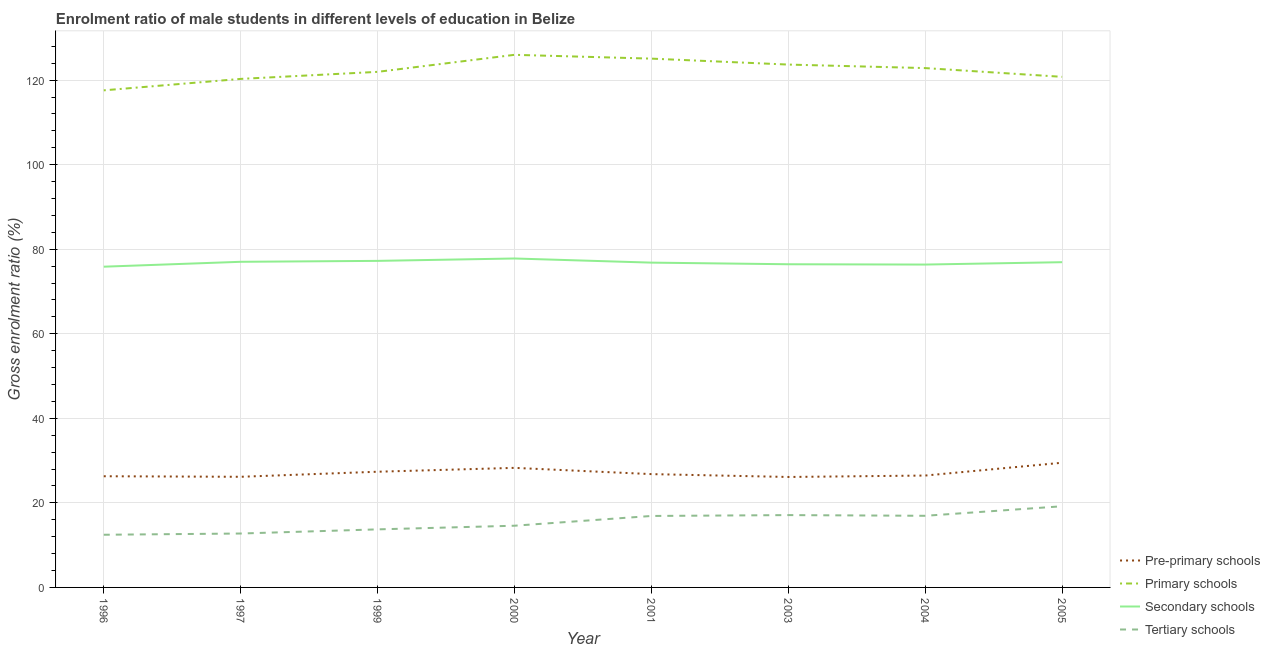Does the line corresponding to gross enrolment ratio(female) in tertiary schools intersect with the line corresponding to gross enrolment ratio(female) in pre-primary schools?
Give a very brief answer. No. What is the gross enrolment ratio(female) in pre-primary schools in 2005?
Your response must be concise. 29.49. Across all years, what is the maximum gross enrolment ratio(female) in primary schools?
Provide a succinct answer. 125.98. Across all years, what is the minimum gross enrolment ratio(female) in pre-primary schools?
Provide a succinct answer. 26.13. In which year was the gross enrolment ratio(female) in secondary schools maximum?
Offer a very short reply. 2000. In which year was the gross enrolment ratio(female) in tertiary schools minimum?
Offer a very short reply. 1996. What is the total gross enrolment ratio(female) in primary schools in the graph?
Offer a very short reply. 978.14. What is the difference between the gross enrolment ratio(female) in pre-primary schools in 1997 and that in 2005?
Your response must be concise. -3.32. What is the difference between the gross enrolment ratio(female) in primary schools in 2001 and the gross enrolment ratio(female) in pre-primary schools in 1999?
Your response must be concise. 97.71. What is the average gross enrolment ratio(female) in pre-primary schools per year?
Provide a succinct answer. 27.12. In the year 1997, what is the difference between the gross enrolment ratio(female) in pre-primary schools and gross enrolment ratio(female) in secondary schools?
Your response must be concise. -50.85. In how many years, is the gross enrolment ratio(female) in pre-primary schools greater than 44 %?
Your answer should be compact. 0. What is the ratio of the gross enrolment ratio(female) in pre-primary schools in 1996 to that in 2001?
Offer a terse response. 0.98. Is the difference between the gross enrolment ratio(female) in pre-primary schools in 1997 and 1999 greater than the difference between the gross enrolment ratio(female) in tertiary schools in 1997 and 1999?
Keep it short and to the point. No. What is the difference between the highest and the second highest gross enrolment ratio(female) in primary schools?
Your answer should be very brief. 0.9. What is the difference between the highest and the lowest gross enrolment ratio(female) in tertiary schools?
Provide a succinct answer. 6.74. Is the sum of the gross enrolment ratio(female) in tertiary schools in 1997 and 2000 greater than the maximum gross enrolment ratio(female) in primary schools across all years?
Provide a succinct answer. No. Is it the case that in every year, the sum of the gross enrolment ratio(female) in pre-primary schools and gross enrolment ratio(female) in primary schools is greater than the gross enrolment ratio(female) in secondary schools?
Give a very brief answer. Yes. Is the gross enrolment ratio(female) in primary schools strictly greater than the gross enrolment ratio(female) in tertiary schools over the years?
Your answer should be compact. Yes. How many years are there in the graph?
Make the answer very short. 8. Are the values on the major ticks of Y-axis written in scientific E-notation?
Your answer should be compact. No. Does the graph contain grids?
Your answer should be compact. Yes. How many legend labels are there?
Keep it short and to the point. 4. How are the legend labels stacked?
Keep it short and to the point. Vertical. What is the title of the graph?
Ensure brevity in your answer.  Enrolment ratio of male students in different levels of education in Belize. What is the Gross enrolment ratio (%) of Pre-primary schools in 1996?
Your answer should be compact. 26.3. What is the Gross enrolment ratio (%) of Primary schools in 1996?
Give a very brief answer. 117.58. What is the Gross enrolment ratio (%) in Secondary schools in 1996?
Offer a very short reply. 75.86. What is the Gross enrolment ratio (%) in Tertiary schools in 1996?
Keep it short and to the point. 12.46. What is the Gross enrolment ratio (%) of Pre-primary schools in 1997?
Keep it short and to the point. 26.17. What is the Gross enrolment ratio (%) of Primary schools in 1997?
Give a very brief answer. 120.28. What is the Gross enrolment ratio (%) of Secondary schools in 1997?
Ensure brevity in your answer.  77.02. What is the Gross enrolment ratio (%) in Tertiary schools in 1997?
Your response must be concise. 12.75. What is the Gross enrolment ratio (%) of Pre-primary schools in 1999?
Ensure brevity in your answer.  27.37. What is the Gross enrolment ratio (%) of Primary schools in 1999?
Your answer should be very brief. 121.95. What is the Gross enrolment ratio (%) in Secondary schools in 1999?
Provide a short and direct response. 77.24. What is the Gross enrolment ratio (%) of Tertiary schools in 1999?
Give a very brief answer. 13.73. What is the Gross enrolment ratio (%) in Pre-primary schools in 2000?
Provide a succinct answer. 28.28. What is the Gross enrolment ratio (%) of Primary schools in 2000?
Your response must be concise. 125.98. What is the Gross enrolment ratio (%) of Secondary schools in 2000?
Your answer should be very brief. 77.8. What is the Gross enrolment ratio (%) in Tertiary schools in 2000?
Offer a terse response. 14.6. What is the Gross enrolment ratio (%) of Pre-primary schools in 2001?
Ensure brevity in your answer.  26.8. What is the Gross enrolment ratio (%) of Primary schools in 2001?
Give a very brief answer. 125.08. What is the Gross enrolment ratio (%) of Secondary schools in 2001?
Offer a very short reply. 76.82. What is the Gross enrolment ratio (%) of Tertiary schools in 2001?
Provide a short and direct response. 16.9. What is the Gross enrolment ratio (%) of Pre-primary schools in 2003?
Your answer should be very brief. 26.13. What is the Gross enrolment ratio (%) of Primary schools in 2003?
Ensure brevity in your answer.  123.67. What is the Gross enrolment ratio (%) of Secondary schools in 2003?
Keep it short and to the point. 76.44. What is the Gross enrolment ratio (%) in Tertiary schools in 2003?
Make the answer very short. 17.11. What is the Gross enrolment ratio (%) of Pre-primary schools in 2004?
Your answer should be compact. 26.46. What is the Gross enrolment ratio (%) of Primary schools in 2004?
Provide a succinct answer. 122.84. What is the Gross enrolment ratio (%) of Secondary schools in 2004?
Offer a terse response. 76.37. What is the Gross enrolment ratio (%) in Tertiary schools in 2004?
Provide a succinct answer. 16.94. What is the Gross enrolment ratio (%) in Pre-primary schools in 2005?
Provide a succinct answer. 29.49. What is the Gross enrolment ratio (%) of Primary schools in 2005?
Offer a terse response. 120.77. What is the Gross enrolment ratio (%) of Secondary schools in 2005?
Keep it short and to the point. 76.93. What is the Gross enrolment ratio (%) in Tertiary schools in 2005?
Give a very brief answer. 19.2. Across all years, what is the maximum Gross enrolment ratio (%) in Pre-primary schools?
Keep it short and to the point. 29.49. Across all years, what is the maximum Gross enrolment ratio (%) in Primary schools?
Ensure brevity in your answer.  125.98. Across all years, what is the maximum Gross enrolment ratio (%) in Secondary schools?
Your response must be concise. 77.8. Across all years, what is the maximum Gross enrolment ratio (%) in Tertiary schools?
Your answer should be compact. 19.2. Across all years, what is the minimum Gross enrolment ratio (%) of Pre-primary schools?
Your response must be concise. 26.13. Across all years, what is the minimum Gross enrolment ratio (%) in Primary schools?
Provide a succinct answer. 117.58. Across all years, what is the minimum Gross enrolment ratio (%) of Secondary schools?
Keep it short and to the point. 75.86. Across all years, what is the minimum Gross enrolment ratio (%) in Tertiary schools?
Ensure brevity in your answer.  12.46. What is the total Gross enrolment ratio (%) of Pre-primary schools in the graph?
Your answer should be very brief. 217. What is the total Gross enrolment ratio (%) of Primary schools in the graph?
Provide a short and direct response. 978.14. What is the total Gross enrolment ratio (%) in Secondary schools in the graph?
Give a very brief answer. 614.49. What is the total Gross enrolment ratio (%) in Tertiary schools in the graph?
Make the answer very short. 123.69. What is the difference between the Gross enrolment ratio (%) in Pre-primary schools in 1996 and that in 1997?
Your answer should be very brief. 0.13. What is the difference between the Gross enrolment ratio (%) of Primary schools in 1996 and that in 1997?
Offer a very short reply. -2.71. What is the difference between the Gross enrolment ratio (%) of Secondary schools in 1996 and that in 1997?
Keep it short and to the point. -1.16. What is the difference between the Gross enrolment ratio (%) of Tertiary schools in 1996 and that in 1997?
Provide a succinct answer. -0.29. What is the difference between the Gross enrolment ratio (%) of Pre-primary schools in 1996 and that in 1999?
Keep it short and to the point. -1.07. What is the difference between the Gross enrolment ratio (%) in Primary schools in 1996 and that in 1999?
Give a very brief answer. -4.37. What is the difference between the Gross enrolment ratio (%) in Secondary schools in 1996 and that in 1999?
Keep it short and to the point. -1.38. What is the difference between the Gross enrolment ratio (%) of Tertiary schools in 1996 and that in 1999?
Your response must be concise. -1.27. What is the difference between the Gross enrolment ratio (%) in Pre-primary schools in 1996 and that in 2000?
Provide a succinct answer. -1.98. What is the difference between the Gross enrolment ratio (%) of Primary schools in 1996 and that in 2000?
Keep it short and to the point. -8.4. What is the difference between the Gross enrolment ratio (%) in Secondary schools in 1996 and that in 2000?
Make the answer very short. -1.94. What is the difference between the Gross enrolment ratio (%) of Tertiary schools in 1996 and that in 2000?
Offer a very short reply. -2.14. What is the difference between the Gross enrolment ratio (%) of Pre-primary schools in 1996 and that in 2001?
Ensure brevity in your answer.  -0.5. What is the difference between the Gross enrolment ratio (%) of Primary schools in 1996 and that in 2001?
Provide a short and direct response. -7.5. What is the difference between the Gross enrolment ratio (%) of Secondary schools in 1996 and that in 2001?
Give a very brief answer. -0.96. What is the difference between the Gross enrolment ratio (%) in Tertiary schools in 1996 and that in 2001?
Ensure brevity in your answer.  -4.44. What is the difference between the Gross enrolment ratio (%) in Pre-primary schools in 1996 and that in 2003?
Give a very brief answer. 0.17. What is the difference between the Gross enrolment ratio (%) in Primary schools in 1996 and that in 2003?
Offer a very short reply. -6.1. What is the difference between the Gross enrolment ratio (%) of Secondary schools in 1996 and that in 2003?
Offer a terse response. -0.58. What is the difference between the Gross enrolment ratio (%) in Tertiary schools in 1996 and that in 2003?
Make the answer very short. -4.65. What is the difference between the Gross enrolment ratio (%) of Pre-primary schools in 1996 and that in 2004?
Keep it short and to the point. -0.17. What is the difference between the Gross enrolment ratio (%) in Primary schools in 1996 and that in 2004?
Ensure brevity in your answer.  -5.26. What is the difference between the Gross enrolment ratio (%) of Secondary schools in 1996 and that in 2004?
Give a very brief answer. -0.5. What is the difference between the Gross enrolment ratio (%) of Tertiary schools in 1996 and that in 2004?
Provide a short and direct response. -4.48. What is the difference between the Gross enrolment ratio (%) in Pre-primary schools in 1996 and that in 2005?
Offer a terse response. -3.2. What is the difference between the Gross enrolment ratio (%) in Primary schools in 1996 and that in 2005?
Ensure brevity in your answer.  -3.2. What is the difference between the Gross enrolment ratio (%) in Secondary schools in 1996 and that in 2005?
Your answer should be compact. -1.06. What is the difference between the Gross enrolment ratio (%) in Tertiary schools in 1996 and that in 2005?
Give a very brief answer. -6.74. What is the difference between the Gross enrolment ratio (%) of Pre-primary schools in 1997 and that in 1999?
Give a very brief answer. -1.2. What is the difference between the Gross enrolment ratio (%) of Primary schools in 1997 and that in 1999?
Your response must be concise. -1.67. What is the difference between the Gross enrolment ratio (%) of Secondary schools in 1997 and that in 1999?
Your answer should be very brief. -0.22. What is the difference between the Gross enrolment ratio (%) of Tertiary schools in 1997 and that in 1999?
Make the answer very short. -0.98. What is the difference between the Gross enrolment ratio (%) in Pre-primary schools in 1997 and that in 2000?
Provide a succinct answer. -2.11. What is the difference between the Gross enrolment ratio (%) in Primary schools in 1997 and that in 2000?
Make the answer very short. -5.7. What is the difference between the Gross enrolment ratio (%) of Secondary schools in 1997 and that in 2000?
Your answer should be compact. -0.78. What is the difference between the Gross enrolment ratio (%) in Tertiary schools in 1997 and that in 2000?
Provide a short and direct response. -1.84. What is the difference between the Gross enrolment ratio (%) in Pre-primary schools in 1997 and that in 2001?
Give a very brief answer. -0.63. What is the difference between the Gross enrolment ratio (%) in Primary schools in 1997 and that in 2001?
Ensure brevity in your answer.  -4.8. What is the difference between the Gross enrolment ratio (%) in Secondary schools in 1997 and that in 2001?
Provide a succinct answer. 0.2. What is the difference between the Gross enrolment ratio (%) in Tertiary schools in 1997 and that in 2001?
Your response must be concise. -4.15. What is the difference between the Gross enrolment ratio (%) in Pre-primary schools in 1997 and that in 2003?
Keep it short and to the point. 0.04. What is the difference between the Gross enrolment ratio (%) of Primary schools in 1997 and that in 2003?
Offer a very short reply. -3.39. What is the difference between the Gross enrolment ratio (%) of Secondary schools in 1997 and that in 2003?
Offer a terse response. 0.58. What is the difference between the Gross enrolment ratio (%) in Tertiary schools in 1997 and that in 2003?
Give a very brief answer. -4.36. What is the difference between the Gross enrolment ratio (%) in Pre-primary schools in 1997 and that in 2004?
Your response must be concise. -0.29. What is the difference between the Gross enrolment ratio (%) of Primary schools in 1997 and that in 2004?
Ensure brevity in your answer.  -2.56. What is the difference between the Gross enrolment ratio (%) in Secondary schools in 1997 and that in 2004?
Make the answer very short. 0.65. What is the difference between the Gross enrolment ratio (%) of Tertiary schools in 1997 and that in 2004?
Your response must be concise. -4.19. What is the difference between the Gross enrolment ratio (%) in Pre-primary schools in 1997 and that in 2005?
Your answer should be very brief. -3.32. What is the difference between the Gross enrolment ratio (%) of Primary schools in 1997 and that in 2005?
Keep it short and to the point. -0.49. What is the difference between the Gross enrolment ratio (%) of Secondary schools in 1997 and that in 2005?
Offer a terse response. 0.09. What is the difference between the Gross enrolment ratio (%) of Tertiary schools in 1997 and that in 2005?
Keep it short and to the point. -6.45. What is the difference between the Gross enrolment ratio (%) in Pre-primary schools in 1999 and that in 2000?
Give a very brief answer. -0.91. What is the difference between the Gross enrolment ratio (%) of Primary schools in 1999 and that in 2000?
Offer a terse response. -4.03. What is the difference between the Gross enrolment ratio (%) in Secondary schools in 1999 and that in 2000?
Provide a succinct answer. -0.56. What is the difference between the Gross enrolment ratio (%) in Tertiary schools in 1999 and that in 2000?
Your answer should be very brief. -0.86. What is the difference between the Gross enrolment ratio (%) in Pre-primary schools in 1999 and that in 2001?
Keep it short and to the point. 0.56. What is the difference between the Gross enrolment ratio (%) of Primary schools in 1999 and that in 2001?
Keep it short and to the point. -3.13. What is the difference between the Gross enrolment ratio (%) of Secondary schools in 1999 and that in 2001?
Offer a terse response. 0.42. What is the difference between the Gross enrolment ratio (%) of Tertiary schools in 1999 and that in 2001?
Your answer should be compact. -3.17. What is the difference between the Gross enrolment ratio (%) of Pre-primary schools in 1999 and that in 2003?
Offer a very short reply. 1.24. What is the difference between the Gross enrolment ratio (%) in Primary schools in 1999 and that in 2003?
Your answer should be very brief. -1.72. What is the difference between the Gross enrolment ratio (%) in Secondary schools in 1999 and that in 2003?
Provide a short and direct response. 0.8. What is the difference between the Gross enrolment ratio (%) in Tertiary schools in 1999 and that in 2003?
Make the answer very short. -3.38. What is the difference between the Gross enrolment ratio (%) in Pre-primary schools in 1999 and that in 2004?
Your answer should be very brief. 0.9. What is the difference between the Gross enrolment ratio (%) of Primary schools in 1999 and that in 2004?
Your answer should be very brief. -0.89. What is the difference between the Gross enrolment ratio (%) in Secondary schools in 1999 and that in 2004?
Your response must be concise. 0.87. What is the difference between the Gross enrolment ratio (%) in Tertiary schools in 1999 and that in 2004?
Your answer should be compact. -3.21. What is the difference between the Gross enrolment ratio (%) of Pre-primary schools in 1999 and that in 2005?
Provide a succinct answer. -2.13. What is the difference between the Gross enrolment ratio (%) of Primary schools in 1999 and that in 2005?
Ensure brevity in your answer.  1.18. What is the difference between the Gross enrolment ratio (%) in Secondary schools in 1999 and that in 2005?
Provide a short and direct response. 0.31. What is the difference between the Gross enrolment ratio (%) in Tertiary schools in 1999 and that in 2005?
Your answer should be very brief. -5.47. What is the difference between the Gross enrolment ratio (%) of Pre-primary schools in 2000 and that in 2001?
Your answer should be compact. 1.48. What is the difference between the Gross enrolment ratio (%) in Primary schools in 2000 and that in 2001?
Your response must be concise. 0.9. What is the difference between the Gross enrolment ratio (%) in Secondary schools in 2000 and that in 2001?
Keep it short and to the point. 0.98. What is the difference between the Gross enrolment ratio (%) in Tertiary schools in 2000 and that in 2001?
Provide a short and direct response. -2.31. What is the difference between the Gross enrolment ratio (%) in Pre-primary schools in 2000 and that in 2003?
Your answer should be very brief. 2.15. What is the difference between the Gross enrolment ratio (%) in Primary schools in 2000 and that in 2003?
Provide a succinct answer. 2.31. What is the difference between the Gross enrolment ratio (%) in Secondary schools in 2000 and that in 2003?
Offer a very short reply. 1.36. What is the difference between the Gross enrolment ratio (%) in Tertiary schools in 2000 and that in 2003?
Give a very brief answer. -2.51. What is the difference between the Gross enrolment ratio (%) in Pre-primary schools in 2000 and that in 2004?
Offer a terse response. 1.82. What is the difference between the Gross enrolment ratio (%) of Primary schools in 2000 and that in 2004?
Ensure brevity in your answer.  3.14. What is the difference between the Gross enrolment ratio (%) of Secondary schools in 2000 and that in 2004?
Offer a very short reply. 1.44. What is the difference between the Gross enrolment ratio (%) of Tertiary schools in 2000 and that in 2004?
Your response must be concise. -2.35. What is the difference between the Gross enrolment ratio (%) of Pre-primary schools in 2000 and that in 2005?
Make the answer very short. -1.21. What is the difference between the Gross enrolment ratio (%) in Primary schools in 2000 and that in 2005?
Give a very brief answer. 5.21. What is the difference between the Gross enrolment ratio (%) in Secondary schools in 2000 and that in 2005?
Offer a very short reply. 0.88. What is the difference between the Gross enrolment ratio (%) in Tertiary schools in 2000 and that in 2005?
Your answer should be compact. -4.6. What is the difference between the Gross enrolment ratio (%) in Pre-primary schools in 2001 and that in 2003?
Ensure brevity in your answer.  0.68. What is the difference between the Gross enrolment ratio (%) in Primary schools in 2001 and that in 2003?
Your answer should be very brief. 1.41. What is the difference between the Gross enrolment ratio (%) in Secondary schools in 2001 and that in 2003?
Your answer should be compact. 0.38. What is the difference between the Gross enrolment ratio (%) of Tertiary schools in 2001 and that in 2003?
Make the answer very short. -0.2. What is the difference between the Gross enrolment ratio (%) of Pre-primary schools in 2001 and that in 2004?
Provide a short and direct response. 0.34. What is the difference between the Gross enrolment ratio (%) of Primary schools in 2001 and that in 2004?
Offer a very short reply. 2.24. What is the difference between the Gross enrolment ratio (%) of Secondary schools in 2001 and that in 2004?
Your answer should be very brief. 0.46. What is the difference between the Gross enrolment ratio (%) of Tertiary schools in 2001 and that in 2004?
Offer a terse response. -0.04. What is the difference between the Gross enrolment ratio (%) of Pre-primary schools in 2001 and that in 2005?
Make the answer very short. -2.69. What is the difference between the Gross enrolment ratio (%) in Primary schools in 2001 and that in 2005?
Your response must be concise. 4.31. What is the difference between the Gross enrolment ratio (%) of Secondary schools in 2001 and that in 2005?
Provide a short and direct response. -0.11. What is the difference between the Gross enrolment ratio (%) in Tertiary schools in 2001 and that in 2005?
Offer a terse response. -2.3. What is the difference between the Gross enrolment ratio (%) in Pre-primary schools in 2003 and that in 2004?
Make the answer very short. -0.34. What is the difference between the Gross enrolment ratio (%) of Primary schools in 2003 and that in 2004?
Give a very brief answer. 0.83. What is the difference between the Gross enrolment ratio (%) of Secondary schools in 2003 and that in 2004?
Give a very brief answer. 0.07. What is the difference between the Gross enrolment ratio (%) in Tertiary schools in 2003 and that in 2004?
Keep it short and to the point. 0.17. What is the difference between the Gross enrolment ratio (%) in Pre-primary schools in 2003 and that in 2005?
Your answer should be very brief. -3.37. What is the difference between the Gross enrolment ratio (%) of Primary schools in 2003 and that in 2005?
Offer a terse response. 2.9. What is the difference between the Gross enrolment ratio (%) in Secondary schools in 2003 and that in 2005?
Your answer should be very brief. -0.49. What is the difference between the Gross enrolment ratio (%) in Tertiary schools in 2003 and that in 2005?
Provide a short and direct response. -2.09. What is the difference between the Gross enrolment ratio (%) in Pre-primary schools in 2004 and that in 2005?
Your response must be concise. -3.03. What is the difference between the Gross enrolment ratio (%) of Primary schools in 2004 and that in 2005?
Offer a very short reply. 2.07. What is the difference between the Gross enrolment ratio (%) of Secondary schools in 2004 and that in 2005?
Provide a succinct answer. -0.56. What is the difference between the Gross enrolment ratio (%) in Tertiary schools in 2004 and that in 2005?
Provide a short and direct response. -2.26. What is the difference between the Gross enrolment ratio (%) of Pre-primary schools in 1996 and the Gross enrolment ratio (%) of Primary schools in 1997?
Keep it short and to the point. -93.98. What is the difference between the Gross enrolment ratio (%) of Pre-primary schools in 1996 and the Gross enrolment ratio (%) of Secondary schools in 1997?
Offer a terse response. -50.72. What is the difference between the Gross enrolment ratio (%) in Pre-primary schools in 1996 and the Gross enrolment ratio (%) in Tertiary schools in 1997?
Keep it short and to the point. 13.55. What is the difference between the Gross enrolment ratio (%) of Primary schools in 1996 and the Gross enrolment ratio (%) of Secondary schools in 1997?
Your answer should be very brief. 40.55. What is the difference between the Gross enrolment ratio (%) in Primary schools in 1996 and the Gross enrolment ratio (%) in Tertiary schools in 1997?
Your answer should be compact. 104.82. What is the difference between the Gross enrolment ratio (%) of Secondary schools in 1996 and the Gross enrolment ratio (%) of Tertiary schools in 1997?
Your answer should be very brief. 63.11. What is the difference between the Gross enrolment ratio (%) in Pre-primary schools in 1996 and the Gross enrolment ratio (%) in Primary schools in 1999?
Make the answer very short. -95.65. What is the difference between the Gross enrolment ratio (%) in Pre-primary schools in 1996 and the Gross enrolment ratio (%) in Secondary schools in 1999?
Give a very brief answer. -50.94. What is the difference between the Gross enrolment ratio (%) in Pre-primary schools in 1996 and the Gross enrolment ratio (%) in Tertiary schools in 1999?
Your answer should be compact. 12.57. What is the difference between the Gross enrolment ratio (%) of Primary schools in 1996 and the Gross enrolment ratio (%) of Secondary schools in 1999?
Provide a succinct answer. 40.33. What is the difference between the Gross enrolment ratio (%) in Primary schools in 1996 and the Gross enrolment ratio (%) in Tertiary schools in 1999?
Your response must be concise. 103.84. What is the difference between the Gross enrolment ratio (%) in Secondary schools in 1996 and the Gross enrolment ratio (%) in Tertiary schools in 1999?
Your answer should be compact. 62.13. What is the difference between the Gross enrolment ratio (%) of Pre-primary schools in 1996 and the Gross enrolment ratio (%) of Primary schools in 2000?
Ensure brevity in your answer.  -99.68. What is the difference between the Gross enrolment ratio (%) in Pre-primary schools in 1996 and the Gross enrolment ratio (%) in Secondary schools in 2000?
Your response must be concise. -51.51. What is the difference between the Gross enrolment ratio (%) of Pre-primary schools in 1996 and the Gross enrolment ratio (%) of Tertiary schools in 2000?
Give a very brief answer. 11.7. What is the difference between the Gross enrolment ratio (%) in Primary schools in 1996 and the Gross enrolment ratio (%) in Secondary schools in 2000?
Provide a short and direct response. 39.77. What is the difference between the Gross enrolment ratio (%) of Primary schools in 1996 and the Gross enrolment ratio (%) of Tertiary schools in 2000?
Make the answer very short. 102.98. What is the difference between the Gross enrolment ratio (%) of Secondary schools in 1996 and the Gross enrolment ratio (%) of Tertiary schools in 2000?
Provide a short and direct response. 61.27. What is the difference between the Gross enrolment ratio (%) in Pre-primary schools in 1996 and the Gross enrolment ratio (%) in Primary schools in 2001?
Your answer should be very brief. -98.78. What is the difference between the Gross enrolment ratio (%) of Pre-primary schools in 1996 and the Gross enrolment ratio (%) of Secondary schools in 2001?
Ensure brevity in your answer.  -50.53. What is the difference between the Gross enrolment ratio (%) of Pre-primary schools in 1996 and the Gross enrolment ratio (%) of Tertiary schools in 2001?
Your answer should be very brief. 9.39. What is the difference between the Gross enrolment ratio (%) of Primary schools in 1996 and the Gross enrolment ratio (%) of Secondary schools in 2001?
Provide a short and direct response. 40.75. What is the difference between the Gross enrolment ratio (%) in Primary schools in 1996 and the Gross enrolment ratio (%) in Tertiary schools in 2001?
Your response must be concise. 100.67. What is the difference between the Gross enrolment ratio (%) in Secondary schools in 1996 and the Gross enrolment ratio (%) in Tertiary schools in 2001?
Give a very brief answer. 58.96. What is the difference between the Gross enrolment ratio (%) in Pre-primary schools in 1996 and the Gross enrolment ratio (%) in Primary schools in 2003?
Your answer should be compact. -97.37. What is the difference between the Gross enrolment ratio (%) in Pre-primary schools in 1996 and the Gross enrolment ratio (%) in Secondary schools in 2003?
Make the answer very short. -50.14. What is the difference between the Gross enrolment ratio (%) in Pre-primary schools in 1996 and the Gross enrolment ratio (%) in Tertiary schools in 2003?
Your answer should be compact. 9.19. What is the difference between the Gross enrolment ratio (%) of Primary schools in 1996 and the Gross enrolment ratio (%) of Secondary schools in 2003?
Your answer should be very brief. 41.13. What is the difference between the Gross enrolment ratio (%) of Primary schools in 1996 and the Gross enrolment ratio (%) of Tertiary schools in 2003?
Keep it short and to the point. 100.47. What is the difference between the Gross enrolment ratio (%) in Secondary schools in 1996 and the Gross enrolment ratio (%) in Tertiary schools in 2003?
Offer a very short reply. 58.76. What is the difference between the Gross enrolment ratio (%) in Pre-primary schools in 1996 and the Gross enrolment ratio (%) in Primary schools in 2004?
Make the answer very short. -96.54. What is the difference between the Gross enrolment ratio (%) in Pre-primary schools in 1996 and the Gross enrolment ratio (%) in Secondary schools in 2004?
Provide a short and direct response. -50.07. What is the difference between the Gross enrolment ratio (%) in Pre-primary schools in 1996 and the Gross enrolment ratio (%) in Tertiary schools in 2004?
Your response must be concise. 9.35. What is the difference between the Gross enrolment ratio (%) in Primary schools in 1996 and the Gross enrolment ratio (%) in Secondary schools in 2004?
Provide a short and direct response. 41.21. What is the difference between the Gross enrolment ratio (%) in Primary schools in 1996 and the Gross enrolment ratio (%) in Tertiary schools in 2004?
Ensure brevity in your answer.  100.63. What is the difference between the Gross enrolment ratio (%) of Secondary schools in 1996 and the Gross enrolment ratio (%) of Tertiary schools in 2004?
Offer a terse response. 58.92. What is the difference between the Gross enrolment ratio (%) of Pre-primary schools in 1996 and the Gross enrolment ratio (%) of Primary schools in 2005?
Your answer should be very brief. -94.47. What is the difference between the Gross enrolment ratio (%) in Pre-primary schools in 1996 and the Gross enrolment ratio (%) in Secondary schools in 2005?
Your answer should be very brief. -50.63. What is the difference between the Gross enrolment ratio (%) in Pre-primary schools in 1996 and the Gross enrolment ratio (%) in Tertiary schools in 2005?
Give a very brief answer. 7.1. What is the difference between the Gross enrolment ratio (%) in Primary schools in 1996 and the Gross enrolment ratio (%) in Secondary schools in 2005?
Ensure brevity in your answer.  40.65. What is the difference between the Gross enrolment ratio (%) in Primary schools in 1996 and the Gross enrolment ratio (%) in Tertiary schools in 2005?
Your answer should be compact. 98.38. What is the difference between the Gross enrolment ratio (%) in Secondary schools in 1996 and the Gross enrolment ratio (%) in Tertiary schools in 2005?
Your response must be concise. 56.67. What is the difference between the Gross enrolment ratio (%) in Pre-primary schools in 1997 and the Gross enrolment ratio (%) in Primary schools in 1999?
Give a very brief answer. -95.78. What is the difference between the Gross enrolment ratio (%) of Pre-primary schools in 1997 and the Gross enrolment ratio (%) of Secondary schools in 1999?
Offer a terse response. -51.07. What is the difference between the Gross enrolment ratio (%) in Pre-primary schools in 1997 and the Gross enrolment ratio (%) in Tertiary schools in 1999?
Your answer should be compact. 12.44. What is the difference between the Gross enrolment ratio (%) in Primary schools in 1997 and the Gross enrolment ratio (%) in Secondary schools in 1999?
Ensure brevity in your answer.  43.04. What is the difference between the Gross enrolment ratio (%) in Primary schools in 1997 and the Gross enrolment ratio (%) in Tertiary schools in 1999?
Your answer should be compact. 106.55. What is the difference between the Gross enrolment ratio (%) of Secondary schools in 1997 and the Gross enrolment ratio (%) of Tertiary schools in 1999?
Your answer should be compact. 63.29. What is the difference between the Gross enrolment ratio (%) in Pre-primary schools in 1997 and the Gross enrolment ratio (%) in Primary schools in 2000?
Your answer should be very brief. -99.81. What is the difference between the Gross enrolment ratio (%) of Pre-primary schools in 1997 and the Gross enrolment ratio (%) of Secondary schools in 2000?
Provide a short and direct response. -51.63. What is the difference between the Gross enrolment ratio (%) in Pre-primary schools in 1997 and the Gross enrolment ratio (%) in Tertiary schools in 2000?
Give a very brief answer. 11.57. What is the difference between the Gross enrolment ratio (%) of Primary schools in 1997 and the Gross enrolment ratio (%) of Secondary schools in 2000?
Give a very brief answer. 42.48. What is the difference between the Gross enrolment ratio (%) in Primary schools in 1997 and the Gross enrolment ratio (%) in Tertiary schools in 2000?
Your answer should be compact. 105.68. What is the difference between the Gross enrolment ratio (%) of Secondary schools in 1997 and the Gross enrolment ratio (%) of Tertiary schools in 2000?
Make the answer very short. 62.42. What is the difference between the Gross enrolment ratio (%) in Pre-primary schools in 1997 and the Gross enrolment ratio (%) in Primary schools in 2001?
Give a very brief answer. -98.91. What is the difference between the Gross enrolment ratio (%) in Pre-primary schools in 1997 and the Gross enrolment ratio (%) in Secondary schools in 2001?
Keep it short and to the point. -50.65. What is the difference between the Gross enrolment ratio (%) in Pre-primary schools in 1997 and the Gross enrolment ratio (%) in Tertiary schools in 2001?
Offer a terse response. 9.27. What is the difference between the Gross enrolment ratio (%) in Primary schools in 1997 and the Gross enrolment ratio (%) in Secondary schools in 2001?
Ensure brevity in your answer.  43.46. What is the difference between the Gross enrolment ratio (%) of Primary schools in 1997 and the Gross enrolment ratio (%) of Tertiary schools in 2001?
Offer a terse response. 103.38. What is the difference between the Gross enrolment ratio (%) in Secondary schools in 1997 and the Gross enrolment ratio (%) in Tertiary schools in 2001?
Offer a very short reply. 60.12. What is the difference between the Gross enrolment ratio (%) in Pre-primary schools in 1997 and the Gross enrolment ratio (%) in Primary schools in 2003?
Give a very brief answer. -97.5. What is the difference between the Gross enrolment ratio (%) in Pre-primary schools in 1997 and the Gross enrolment ratio (%) in Secondary schools in 2003?
Provide a short and direct response. -50.27. What is the difference between the Gross enrolment ratio (%) of Pre-primary schools in 1997 and the Gross enrolment ratio (%) of Tertiary schools in 2003?
Keep it short and to the point. 9.06. What is the difference between the Gross enrolment ratio (%) in Primary schools in 1997 and the Gross enrolment ratio (%) in Secondary schools in 2003?
Provide a short and direct response. 43.84. What is the difference between the Gross enrolment ratio (%) in Primary schools in 1997 and the Gross enrolment ratio (%) in Tertiary schools in 2003?
Your response must be concise. 103.17. What is the difference between the Gross enrolment ratio (%) in Secondary schools in 1997 and the Gross enrolment ratio (%) in Tertiary schools in 2003?
Provide a short and direct response. 59.91. What is the difference between the Gross enrolment ratio (%) of Pre-primary schools in 1997 and the Gross enrolment ratio (%) of Primary schools in 2004?
Keep it short and to the point. -96.67. What is the difference between the Gross enrolment ratio (%) of Pre-primary schools in 1997 and the Gross enrolment ratio (%) of Secondary schools in 2004?
Make the answer very short. -50.2. What is the difference between the Gross enrolment ratio (%) of Pre-primary schools in 1997 and the Gross enrolment ratio (%) of Tertiary schools in 2004?
Your answer should be compact. 9.23. What is the difference between the Gross enrolment ratio (%) of Primary schools in 1997 and the Gross enrolment ratio (%) of Secondary schools in 2004?
Your answer should be compact. 43.91. What is the difference between the Gross enrolment ratio (%) of Primary schools in 1997 and the Gross enrolment ratio (%) of Tertiary schools in 2004?
Your answer should be compact. 103.34. What is the difference between the Gross enrolment ratio (%) in Secondary schools in 1997 and the Gross enrolment ratio (%) in Tertiary schools in 2004?
Your response must be concise. 60.08. What is the difference between the Gross enrolment ratio (%) of Pre-primary schools in 1997 and the Gross enrolment ratio (%) of Primary schools in 2005?
Make the answer very short. -94.6. What is the difference between the Gross enrolment ratio (%) in Pre-primary schools in 1997 and the Gross enrolment ratio (%) in Secondary schools in 2005?
Provide a succinct answer. -50.76. What is the difference between the Gross enrolment ratio (%) in Pre-primary schools in 1997 and the Gross enrolment ratio (%) in Tertiary schools in 2005?
Offer a very short reply. 6.97. What is the difference between the Gross enrolment ratio (%) in Primary schools in 1997 and the Gross enrolment ratio (%) in Secondary schools in 2005?
Offer a very short reply. 43.35. What is the difference between the Gross enrolment ratio (%) in Primary schools in 1997 and the Gross enrolment ratio (%) in Tertiary schools in 2005?
Give a very brief answer. 101.08. What is the difference between the Gross enrolment ratio (%) in Secondary schools in 1997 and the Gross enrolment ratio (%) in Tertiary schools in 2005?
Provide a succinct answer. 57.82. What is the difference between the Gross enrolment ratio (%) in Pre-primary schools in 1999 and the Gross enrolment ratio (%) in Primary schools in 2000?
Ensure brevity in your answer.  -98.61. What is the difference between the Gross enrolment ratio (%) of Pre-primary schools in 1999 and the Gross enrolment ratio (%) of Secondary schools in 2000?
Your response must be concise. -50.44. What is the difference between the Gross enrolment ratio (%) of Pre-primary schools in 1999 and the Gross enrolment ratio (%) of Tertiary schools in 2000?
Your answer should be very brief. 12.77. What is the difference between the Gross enrolment ratio (%) of Primary schools in 1999 and the Gross enrolment ratio (%) of Secondary schools in 2000?
Your response must be concise. 44.14. What is the difference between the Gross enrolment ratio (%) in Primary schools in 1999 and the Gross enrolment ratio (%) in Tertiary schools in 2000?
Provide a succinct answer. 107.35. What is the difference between the Gross enrolment ratio (%) in Secondary schools in 1999 and the Gross enrolment ratio (%) in Tertiary schools in 2000?
Offer a terse response. 62.64. What is the difference between the Gross enrolment ratio (%) of Pre-primary schools in 1999 and the Gross enrolment ratio (%) of Primary schools in 2001?
Your answer should be very brief. -97.71. What is the difference between the Gross enrolment ratio (%) in Pre-primary schools in 1999 and the Gross enrolment ratio (%) in Secondary schools in 2001?
Your response must be concise. -49.46. What is the difference between the Gross enrolment ratio (%) in Pre-primary schools in 1999 and the Gross enrolment ratio (%) in Tertiary schools in 2001?
Offer a terse response. 10.46. What is the difference between the Gross enrolment ratio (%) of Primary schools in 1999 and the Gross enrolment ratio (%) of Secondary schools in 2001?
Give a very brief answer. 45.12. What is the difference between the Gross enrolment ratio (%) of Primary schools in 1999 and the Gross enrolment ratio (%) of Tertiary schools in 2001?
Ensure brevity in your answer.  105.04. What is the difference between the Gross enrolment ratio (%) in Secondary schools in 1999 and the Gross enrolment ratio (%) in Tertiary schools in 2001?
Ensure brevity in your answer.  60.34. What is the difference between the Gross enrolment ratio (%) of Pre-primary schools in 1999 and the Gross enrolment ratio (%) of Primary schools in 2003?
Your answer should be compact. -96.3. What is the difference between the Gross enrolment ratio (%) in Pre-primary schools in 1999 and the Gross enrolment ratio (%) in Secondary schools in 2003?
Offer a very short reply. -49.07. What is the difference between the Gross enrolment ratio (%) in Pre-primary schools in 1999 and the Gross enrolment ratio (%) in Tertiary schools in 2003?
Make the answer very short. 10.26. What is the difference between the Gross enrolment ratio (%) of Primary schools in 1999 and the Gross enrolment ratio (%) of Secondary schools in 2003?
Keep it short and to the point. 45.51. What is the difference between the Gross enrolment ratio (%) in Primary schools in 1999 and the Gross enrolment ratio (%) in Tertiary schools in 2003?
Keep it short and to the point. 104.84. What is the difference between the Gross enrolment ratio (%) of Secondary schools in 1999 and the Gross enrolment ratio (%) of Tertiary schools in 2003?
Provide a short and direct response. 60.13. What is the difference between the Gross enrolment ratio (%) of Pre-primary schools in 1999 and the Gross enrolment ratio (%) of Primary schools in 2004?
Give a very brief answer. -95.47. What is the difference between the Gross enrolment ratio (%) in Pre-primary schools in 1999 and the Gross enrolment ratio (%) in Secondary schools in 2004?
Your answer should be very brief. -49. What is the difference between the Gross enrolment ratio (%) of Pre-primary schools in 1999 and the Gross enrolment ratio (%) of Tertiary schools in 2004?
Keep it short and to the point. 10.42. What is the difference between the Gross enrolment ratio (%) in Primary schools in 1999 and the Gross enrolment ratio (%) in Secondary schools in 2004?
Make the answer very short. 45.58. What is the difference between the Gross enrolment ratio (%) of Primary schools in 1999 and the Gross enrolment ratio (%) of Tertiary schools in 2004?
Your answer should be compact. 105. What is the difference between the Gross enrolment ratio (%) in Secondary schools in 1999 and the Gross enrolment ratio (%) in Tertiary schools in 2004?
Make the answer very short. 60.3. What is the difference between the Gross enrolment ratio (%) in Pre-primary schools in 1999 and the Gross enrolment ratio (%) in Primary schools in 2005?
Give a very brief answer. -93.4. What is the difference between the Gross enrolment ratio (%) in Pre-primary schools in 1999 and the Gross enrolment ratio (%) in Secondary schools in 2005?
Provide a short and direct response. -49.56. What is the difference between the Gross enrolment ratio (%) of Pre-primary schools in 1999 and the Gross enrolment ratio (%) of Tertiary schools in 2005?
Provide a short and direct response. 8.17. What is the difference between the Gross enrolment ratio (%) of Primary schools in 1999 and the Gross enrolment ratio (%) of Secondary schools in 2005?
Ensure brevity in your answer.  45.02. What is the difference between the Gross enrolment ratio (%) of Primary schools in 1999 and the Gross enrolment ratio (%) of Tertiary schools in 2005?
Your answer should be compact. 102.75. What is the difference between the Gross enrolment ratio (%) of Secondary schools in 1999 and the Gross enrolment ratio (%) of Tertiary schools in 2005?
Make the answer very short. 58.04. What is the difference between the Gross enrolment ratio (%) in Pre-primary schools in 2000 and the Gross enrolment ratio (%) in Primary schools in 2001?
Give a very brief answer. -96.8. What is the difference between the Gross enrolment ratio (%) in Pre-primary schools in 2000 and the Gross enrolment ratio (%) in Secondary schools in 2001?
Provide a short and direct response. -48.54. What is the difference between the Gross enrolment ratio (%) of Pre-primary schools in 2000 and the Gross enrolment ratio (%) of Tertiary schools in 2001?
Keep it short and to the point. 11.38. What is the difference between the Gross enrolment ratio (%) of Primary schools in 2000 and the Gross enrolment ratio (%) of Secondary schools in 2001?
Make the answer very short. 49.15. What is the difference between the Gross enrolment ratio (%) of Primary schools in 2000 and the Gross enrolment ratio (%) of Tertiary schools in 2001?
Keep it short and to the point. 109.07. What is the difference between the Gross enrolment ratio (%) of Secondary schools in 2000 and the Gross enrolment ratio (%) of Tertiary schools in 2001?
Keep it short and to the point. 60.9. What is the difference between the Gross enrolment ratio (%) in Pre-primary schools in 2000 and the Gross enrolment ratio (%) in Primary schools in 2003?
Offer a terse response. -95.39. What is the difference between the Gross enrolment ratio (%) in Pre-primary schools in 2000 and the Gross enrolment ratio (%) in Secondary schools in 2003?
Provide a short and direct response. -48.16. What is the difference between the Gross enrolment ratio (%) in Pre-primary schools in 2000 and the Gross enrolment ratio (%) in Tertiary schools in 2003?
Ensure brevity in your answer.  11.17. What is the difference between the Gross enrolment ratio (%) of Primary schools in 2000 and the Gross enrolment ratio (%) of Secondary schools in 2003?
Provide a succinct answer. 49.53. What is the difference between the Gross enrolment ratio (%) in Primary schools in 2000 and the Gross enrolment ratio (%) in Tertiary schools in 2003?
Offer a very short reply. 108.87. What is the difference between the Gross enrolment ratio (%) in Secondary schools in 2000 and the Gross enrolment ratio (%) in Tertiary schools in 2003?
Offer a terse response. 60.7. What is the difference between the Gross enrolment ratio (%) of Pre-primary schools in 2000 and the Gross enrolment ratio (%) of Primary schools in 2004?
Offer a very short reply. -94.56. What is the difference between the Gross enrolment ratio (%) in Pre-primary schools in 2000 and the Gross enrolment ratio (%) in Secondary schools in 2004?
Your response must be concise. -48.09. What is the difference between the Gross enrolment ratio (%) in Pre-primary schools in 2000 and the Gross enrolment ratio (%) in Tertiary schools in 2004?
Give a very brief answer. 11.34. What is the difference between the Gross enrolment ratio (%) in Primary schools in 2000 and the Gross enrolment ratio (%) in Secondary schools in 2004?
Your answer should be compact. 49.61. What is the difference between the Gross enrolment ratio (%) in Primary schools in 2000 and the Gross enrolment ratio (%) in Tertiary schools in 2004?
Your answer should be compact. 109.03. What is the difference between the Gross enrolment ratio (%) in Secondary schools in 2000 and the Gross enrolment ratio (%) in Tertiary schools in 2004?
Your response must be concise. 60.86. What is the difference between the Gross enrolment ratio (%) of Pre-primary schools in 2000 and the Gross enrolment ratio (%) of Primary schools in 2005?
Make the answer very short. -92.49. What is the difference between the Gross enrolment ratio (%) in Pre-primary schools in 2000 and the Gross enrolment ratio (%) in Secondary schools in 2005?
Provide a succinct answer. -48.65. What is the difference between the Gross enrolment ratio (%) of Pre-primary schools in 2000 and the Gross enrolment ratio (%) of Tertiary schools in 2005?
Keep it short and to the point. 9.08. What is the difference between the Gross enrolment ratio (%) in Primary schools in 2000 and the Gross enrolment ratio (%) in Secondary schools in 2005?
Offer a very short reply. 49.05. What is the difference between the Gross enrolment ratio (%) of Primary schools in 2000 and the Gross enrolment ratio (%) of Tertiary schools in 2005?
Ensure brevity in your answer.  106.78. What is the difference between the Gross enrolment ratio (%) of Secondary schools in 2000 and the Gross enrolment ratio (%) of Tertiary schools in 2005?
Make the answer very short. 58.61. What is the difference between the Gross enrolment ratio (%) in Pre-primary schools in 2001 and the Gross enrolment ratio (%) in Primary schools in 2003?
Provide a short and direct response. -96.87. What is the difference between the Gross enrolment ratio (%) in Pre-primary schools in 2001 and the Gross enrolment ratio (%) in Secondary schools in 2003?
Give a very brief answer. -49.64. What is the difference between the Gross enrolment ratio (%) in Pre-primary schools in 2001 and the Gross enrolment ratio (%) in Tertiary schools in 2003?
Offer a very short reply. 9.69. What is the difference between the Gross enrolment ratio (%) in Primary schools in 2001 and the Gross enrolment ratio (%) in Secondary schools in 2003?
Give a very brief answer. 48.64. What is the difference between the Gross enrolment ratio (%) of Primary schools in 2001 and the Gross enrolment ratio (%) of Tertiary schools in 2003?
Provide a short and direct response. 107.97. What is the difference between the Gross enrolment ratio (%) in Secondary schools in 2001 and the Gross enrolment ratio (%) in Tertiary schools in 2003?
Your answer should be very brief. 59.72. What is the difference between the Gross enrolment ratio (%) in Pre-primary schools in 2001 and the Gross enrolment ratio (%) in Primary schools in 2004?
Provide a short and direct response. -96.04. What is the difference between the Gross enrolment ratio (%) of Pre-primary schools in 2001 and the Gross enrolment ratio (%) of Secondary schools in 2004?
Offer a terse response. -49.57. What is the difference between the Gross enrolment ratio (%) in Pre-primary schools in 2001 and the Gross enrolment ratio (%) in Tertiary schools in 2004?
Your response must be concise. 9.86. What is the difference between the Gross enrolment ratio (%) of Primary schools in 2001 and the Gross enrolment ratio (%) of Secondary schools in 2004?
Give a very brief answer. 48.71. What is the difference between the Gross enrolment ratio (%) in Primary schools in 2001 and the Gross enrolment ratio (%) in Tertiary schools in 2004?
Provide a short and direct response. 108.13. What is the difference between the Gross enrolment ratio (%) in Secondary schools in 2001 and the Gross enrolment ratio (%) in Tertiary schools in 2004?
Ensure brevity in your answer.  59.88. What is the difference between the Gross enrolment ratio (%) in Pre-primary schools in 2001 and the Gross enrolment ratio (%) in Primary schools in 2005?
Your answer should be very brief. -93.97. What is the difference between the Gross enrolment ratio (%) in Pre-primary schools in 2001 and the Gross enrolment ratio (%) in Secondary schools in 2005?
Offer a terse response. -50.13. What is the difference between the Gross enrolment ratio (%) of Pre-primary schools in 2001 and the Gross enrolment ratio (%) of Tertiary schools in 2005?
Make the answer very short. 7.6. What is the difference between the Gross enrolment ratio (%) of Primary schools in 2001 and the Gross enrolment ratio (%) of Secondary schools in 2005?
Offer a very short reply. 48.15. What is the difference between the Gross enrolment ratio (%) in Primary schools in 2001 and the Gross enrolment ratio (%) in Tertiary schools in 2005?
Your answer should be very brief. 105.88. What is the difference between the Gross enrolment ratio (%) of Secondary schools in 2001 and the Gross enrolment ratio (%) of Tertiary schools in 2005?
Offer a very short reply. 57.63. What is the difference between the Gross enrolment ratio (%) of Pre-primary schools in 2003 and the Gross enrolment ratio (%) of Primary schools in 2004?
Ensure brevity in your answer.  -96.71. What is the difference between the Gross enrolment ratio (%) in Pre-primary schools in 2003 and the Gross enrolment ratio (%) in Secondary schools in 2004?
Your answer should be compact. -50.24. What is the difference between the Gross enrolment ratio (%) of Pre-primary schools in 2003 and the Gross enrolment ratio (%) of Tertiary schools in 2004?
Provide a short and direct response. 9.18. What is the difference between the Gross enrolment ratio (%) of Primary schools in 2003 and the Gross enrolment ratio (%) of Secondary schools in 2004?
Ensure brevity in your answer.  47.3. What is the difference between the Gross enrolment ratio (%) of Primary schools in 2003 and the Gross enrolment ratio (%) of Tertiary schools in 2004?
Provide a succinct answer. 106.73. What is the difference between the Gross enrolment ratio (%) in Secondary schools in 2003 and the Gross enrolment ratio (%) in Tertiary schools in 2004?
Your answer should be compact. 59.5. What is the difference between the Gross enrolment ratio (%) in Pre-primary schools in 2003 and the Gross enrolment ratio (%) in Primary schools in 2005?
Provide a short and direct response. -94.65. What is the difference between the Gross enrolment ratio (%) in Pre-primary schools in 2003 and the Gross enrolment ratio (%) in Secondary schools in 2005?
Provide a short and direct response. -50.8. What is the difference between the Gross enrolment ratio (%) of Pre-primary schools in 2003 and the Gross enrolment ratio (%) of Tertiary schools in 2005?
Your answer should be compact. 6.93. What is the difference between the Gross enrolment ratio (%) in Primary schools in 2003 and the Gross enrolment ratio (%) in Secondary schools in 2005?
Your answer should be very brief. 46.74. What is the difference between the Gross enrolment ratio (%) of Primary schools in 2003 and the Gross enrolment ratio (%) of Tertiary schools in 2005?
Make the answer very short. 104.47. What is the difference between the Gross enrolment ratio (%) in Secondary schools in 2003 and the Gross enrolment ratio (%) in Tertiary schools in 2005?
Offer a very short reply. 57.24. What is the difference between the Gross enrolment ratio (%) of Pre-primary schools in 2004 and the Gross enrolment ratio (%) of Primary schools in 2005?
Provide a short and direct response. -94.31. What is the difference between the Gross enrolment ratio (%) in Pre-primary schools in 2004 and the Gross enrolment ratio (%) in Secondary schools in 2005?
Offer a terse response. -50.47. What is the difference between the Gross enrolment ratio (%) of Pre-primary schools in 2004 and the Gross enrolment ratio (%) of Tertiary schools in 2005?
Ensure brevity in your answer.  7.26. What is the difference between the Gross enrolment ratio (%) of Primary schools in 2004 and the Gross enrolment ratio (%) of Secondary schools in 2005?
Your answer should be compact. 45.91. What is the difference between the Gross enrolment ratio (%) of Primary schools in 2004 and the Gross enrolment ratio (%) of Tertiary schools in 2005?
Your response must be concise. 103.64. What is the difference between the Gross enrolment ratio (%) of Secondary schools in 2004 and the Gross enrolment ratio (%) of Tertiary schools in 2005?
Ensure brevity in your answer.  57.17. What is the average Gross enrolment ratio (%) of Pre-primary schools per year?
Your answer should be very brief. 27.12. What is the average Gross enrolment ratio (%) of Primary schools per year?
Give a very brief answer. 122.27. What is the average Gross enrolment ratio (%) in Secondary schools per year?
Give a very brief answer. 76.81. What is the average Gross enrolment ratio (%) of Tertiary schools per year?
Provide a succinct answer. 15.46. In the year 1996, what is the difference between the Gross enrolment ratio (%) in Pre-primary schools and Gross enrolment ratio (%) in Primary schools?
Offer a terse response. -91.28. In the year 1996, what is the difference between the Gross enrolment ratio (%) of Pre-primary schools and Gross enrolment ratio (%) of Secondary schools?
Your answer should be very brief. -49.57. In the year 1996, what is the difference between the Gross enrolment ratio (%) in Pre-primary schools and Gross enrolment ratio (%) in Tertiary schools?
Provide a succinct answer. 13.84. In the year 1996, what is the difference between the Gross enrolment ratio (%) of Primary schools and Gross enrolment ratio (%) of Secondary schools?
Give a very brief answer. 41.71. In the year 1996, what is the difference between the Gross enrolment ratio (%) of Primary schools and Gross enrolment ratio (%) of Tertiary schools?
Give a very brief answer. 105.12. In the year 1996, what is the difference between the Gross enrolment ratio (%) of Secondary schools and Gross enrolment ratio (%) of Tertiary schools?
Your answer should be very brief. 63.41. In the year 1997, what is the difference between the Gross enrolment ratio (%) in Pre-primary schools and Gross enrolment ratio (%) in Primary schools?
Offer a terse response. -94.11. In the year 1997, what is the difference between the Gross enrolment ratio (%) in Pre-primary schools and Gross enrolment ratio (%) in Secondary schools?
Offer a very short reply. -50.85. In the year 1997, what is the difference between the Gross enrolment ratio (%) in Pre-primary schools and Gross enrolment ratio (%) in Tertiary schools?
Keep it short and to the point. 13.42. In the year 1997, what is the difference between the Gross enrolment ratio (%) of Primary schools and Gross enrolment ratio (%) of Secondary schools?
Provide a succinct answer. 43.26. In the year 1997, what is the difference between the Gross enrolment ratio (%) of Primary schools and Gross enrolment ratio (%) of Tertiary schools?
Your answer should be very brief. 107.53. In the year 1997, what is the difference between the Gross enrolment ratio (%) in Secondary schools and Gross enrolment ratio (%) in Tertiary schools?
Provide a short and direct response. 64.27. In the year 1999, what is the difference between the Gross enrolment ratio (%) in Pre-primary schools and Gross enrolment ratio (%) in Primary schools?
Make the answer very short. -94.58. In the year 1999, what is the difference between the Gross enrolment ratio (%) of Pre-primary schools and Gross enrolment ratio (%) of Secondary schools?
Ensure brevity in your answer.  -49.87. In the year 1999, what is the difference between the Gross enrolment ratio (%) in Pre-primary schools and Gross enrolment ratio (%) in Tertiary schools?
Your response must be concise. 13.64. In the year 1999, what is the difference between the Gross enrolment ratio (%) of Primary schools and Gross enrolment ratio (%) of Secondary schools?
Your answer should be compact. 44.71. In the year 1999, what is the difference between the Gross enrolment ratio (%) of Primary schools and Gross enrolment ratio (%) of Tertiary schools?
Your answer should be very brief. 108.22. In the year 1999, what is the difference between the Gross enrolment ratio (%) of Secondary schools and Gross enrolment ratio (%) of Tertiary schools?
Your answer should be very brief. 63.51. In the year 2000, what is the difference between the Gross enrolment ratio (%) in Pre-primary schools and Gross enrolment ratio (%) in Primary schools?
Make the answer very short. -97.7. In the year 2000, what is the difference between the Gross enrolment ratio (%) of Pre-primary schools and Gross enrolment ratio (%) of Secondary schools?
Ensure brevity in your answer.  -49.52. In the year 2000, what is the difference between the Gross enrolment ratio (%) of Pre-primary schools and Gross enrolment ratio (%) of Tertiary schools?
Provide a succinct answer. 13.68. In the year 2000, what is the difference between the Gross enrolment ratio (%) in Primary schools and Gross enrolment ratio (%) in Secondary schools?
Provide a succinct answer. 48.17. In the year 2000, what is the difference between the Gross enrolment ratio (%) in Primary schools and Gross enrolment ratio (%) in Tertiary schools?
Your response must be concise. 111.38. In the year 2000, what is the difference between the Gross enrolment ratio (%) in Secondary schools and Gross enrolment ratio (%) in Tertiary schools?
Make the answer very short. 63.21. In the year 2001, what is the difference between the Gross enrolment ratio (%) in Pre-primary schools and Gross enrolment ratio (%) in Primary schools?
Give a very brief answer. -98.28. In the year 2001, what is the difference between the Gross enrolment ratio (%) of Pre-primary schools and Gross enrolment ratio (%) of Secondary schools?
Offer a terse response. -50.02. In the year 2001, what is the difference between the Gross enrolment ratio (%) in Pre-primary schools and Gross enrolment ratio (%) in Tertiary schools?
Provide a short and direct response. 9.9. In the year 2001, what is the difference between the Gross enrolment ratio (%) in Primary schools and Gross enrolment ratio (%) in Secondary schools?
Your answer should be very brief. 48.25. In the year 2001, what is the difference between the Gross enrolment ratio (%) of Primary schools and Gross enrolment ratio (%) of Tertiary schools?
Ensure brevity in your answer.  108.17. In the year 2001, what is the difference between the Gross enrolment ratio (%) in Secondary schools and Gross enrolment ratio (%) in Tertiary schools?
Provide a short and direct response. 59.92. In the year 2003, what is the difference between the Gross enrolment ratio (%) in Pre-primary schools and Gross enrolment ratio (%) in Primary schools?
Provide a short and direct response. -97.55. In the year 2003, what is the difference between the Gross enrolment ratio (%) of Pre-primary schools and Gross enrolment ratio (%) of Secondary schools?
Your answer should be very brief. -50.32. In the year 2003, what is the difference between the Gross enrolment ratio (%) in Pre-primary schools and Gross enrolment ratio (%) in Tertiary schools?
Your answer should be very brief. 9.02. In the year 2003, what is the difference between the Gross enrolment ratio (%) of Primary schools and Gross enrolment ratio (%) of Secondary schools?
Ensure brevity in your answer.  47.23. In the year 2003, what is the difference between the Gross enrolment ratio (%) of Primary schools and Gross enrolment ratio (%) of Tertiary schools?
Offer a terse response. 106.56. In the year 2003, what is the difference between the Gross enrolment ratio (%) in Secondary schools and Gross enrolment ratio (%) in Tertiary schools?
Provide a succinct answer. 59.33. In the year 2004, what is the difference between the Gross enrolment ratio (%) in Pre-primary schools and Gross enrolment ratio (%) in Primary schools?
Ensure brevity in your answer.  -96.38. In the year 2004, what is the difference between the Gross enrolment ratio (%) of Pre-primary schools and Gross enrolment ratio (%) of Secondary schools?
Make the answer very short. -49.91. In the year 2004, what is the difference between the Gross enrolment ratio (%) of Pre-primary schools and Gross enrolment ratio (%) of Tertiary schools?
Offer a very short reply. 9.52. In the year 2004, what is the difference between the Gross enrolment ratio (%) in Primary schools and Gross enrolment ratio (%) in Secondary schools?
Keep it short and to the point. 46.47. In the year 2004, what is the difference between the Gross enrolment ratio (%) of Primary schools and Gross enrolment ratio (%) of Tertiary schools?
Your response must be concise. 105.9. In the year 2004, what is the difference between the Gross enrolment ratio (%) of Secondary schools and Gross enrolment ratio (%) of Tertiary schools?
Offer a terse response. 59.43. In the year 2005, what is the difference between the Gross enrolment ratio (%) of Pre-primary schools and Gross enrolment ratio (%) of Primary schools?
Offer a terse response. -91.28. In the year 2005, what is the difference between the Gross enrolment ratio (%) in Pre-primary schools and Gross enrolment ratio (%) in Secondary schools?
Provide a succinct answer. -47.44. In the year 2005, what is the difference between the Gross enrolment ratio (%) of Pre-primary schools and Gross enrolment ratio (%) of Tertiary schools?
Keep it short and to the point. 10.3. In the year 2005, what is the difference between the Gross enrolment ratio (%) of Primary schools and Gross enrolment ratio (%) of Secondary schools?
Your answer should be compact. 43.84. In the year 2005, what is the difference between the Gross enrolment ratio (%) in Primary schools and Gross enrolment ratio (%) in Tertiary schools?
Ensure brevity in your answer.  101.57. In the year 2005, what is the difference between the Gross enrolment ratio (%) in Secondary schools and Gross enrolment ratio (%) in Tertiary schools?
Your answer should be compact. 57.73. What is the ratio of the Gross enrolment ratio (%) in Pre-primary schools in 1996 to that in 1997?
Ensure brevity in your answer.  1. What is the ratio of the Gross enrolment ratio (%) in Primary schools in 1996 to that in 1997?
Give a very brief answer. 0.98. What is the ratio of the Gross enrolment ratio (%) of Pre-primary schools in 1996 to that in 1999?
Provide a succinct answer. 0.96. What is the ratio of the Gross enrolment ratio (%) of Primary schools in 1996 to that in 1999?
Provide a short and direct response. 0.96. What is the ratio of the Gross enrolment ratio (%) of Secondary schools in 1996 to that in 1999?
Keep it short and to the point. 0.98. What is the ratio of the Gross enrolment ratio (%) in Tertiary schools in 1996 to that in 1999?
Your answer should be very brief. 0.91. What is the ratio of the Gross enrolment ratio (%) in Pre-primary schools in 1996 to that in 2000?
Give a very brief answer. 0.93. What is the ratio of the Gross enrolment ratio (%) of Primary schools in 1996 to that in 2000?
Make the answer very short. 0.93. What is the ratio of the Gross enrolment ratio (%) in Secondary schools in 1996 to that in 2000?
Give a very brief answer. 0.98. What is the ratio of the Gross enrolment ratio (%) of Tertiary schools in 1996 to that in 2000?
Keep it short and to the point. 0.85. What is the ratio of the Gross enrolment ratio (%) in Pre-primary schools in 1996 to that in 2001?
Ensure brevity in your answer.  0.98. What is the ratio of the Gross enrolment ratio (%) in Primary schools in 1996 to that in 2001?
Your answer should be compact. 0.94. What is the ratio of the Gross enrolment ratio (%) of Secondary schools in 1996 to that in 2001?
Ensure brevity in your answer.  0.99. What is the ratio of the Gross enrolment ratio (%) in Tertiary schools in 1996 to that in 2001?
Keep it short and to the point. 0.74. What is the ratio of the Gross enrolment ratio (%) of Pre-primary schools in 1996 to that in 2003?
Keep it short and to the point. 1.01. What is the ratio of the Gross enrolment ratio (%) in Primary schools in 1996 to that in 2003?
Ensure brevity in your answer.  0.95. What is the ratio of the Gross enrolment ratio (%) in Tertiary schools in 1996 to that in 2003?
Offer a very short reply. 0.73. What is the ratio of the Gross enrolment ratio (%) of Pre-primary schools in 1996 to that in 2004?
Keep it short and to the point. 0.99. What is the ratio of the Gross enrolment ratio (%) of Primary schools in 1996 to that in 2004?
Provide a succinct answer. 0.96. What is the ratio of the Gross enrolment ratio (%) in Secondary schools in 1996 to that in 2004?
Make the answer very short. 0.99. What is the ratio of the Gross enrolment ratio (%) of Tertiary schools in 1996 to that in 2004?
Provide a succinct answer. 0.74. What is the ratio of the Gross enrolment ratio (%) in Pre-primary schools in 1996 to that in 2005?
Offer a terse response. 0.89. What is the ratio of the Gross enrolment ratio (%) of Primary schools in 1996 to that in 2005?
Provide a short and direct response. 0.97. What is the ratio of the Gross enrolment ratio (%) of Secondary schools in 1996 to that in 2005?
Provide a short and direct response. 0.99. What is the ratio of the Gross enrolment ratio (%) in Tertiary schools in 1996 to that in 2005?
Offer a terse response. 0.65. What is the ratio of the Gross enrolment ratio (%) in Pre-primary schools in 1997 to that in 1999?
Your response must be concise. 0.96. What is the ratio of the Gross enrolment ratio (%) of Primary schools in 1997 to that in 1999?
Keep it short and to the point. 0.99. What is the ratio of the Gross enrolment ratio (%) of Secondary schools in 1997 to that in 1999?
Keep it short and to the point. 1. What is the ratio of the Gross enrolment ratio (%) of Pre-primary schools in 1997 to that in 2000?
Your answer should be very brief. 0.93. What is the ratio of the Gross enrolment ratio (%) of Primary schools in 1997 to that in 2000?
Your answer should be compact. 0.95. What is the ratio of the Gross enrolment ratio (%) of Secondary schools in 1997 to that in 2000?
Your answer should be very brief. 0.99. What is the ratio of the Gross enrolment ratio (%) in Tertiary schools in 1997 to that in 2000?
Keep it short and to the point. 0.87. What is the ratio of the Gross enrolment ratio (%) of Pre-primary schools in 1997 to that in 2001?
Ensure brevity in your answer.  0.98. What is the ratio of the Gross enrolment ratio (%) of Primary schools in 1997 to that in 2001?
Give a very brief answer. 0.96. What is the ratio of the Gross enrolment ratio (%) in Secondary schools in 1997 to that in 2001?
Provide a succinct answer. 1. What is the ratio of the Gross enrolment ratio (%) of Tertiary schools in 1997 to that in 2001?
Ensure brevity in your answer.  0.75. What is the ratio of the Gross enrolment ratio (%) of Pre-primary schools in 1997 to that in 2003?
Your response must be concise. 1. What is the ratio of the Gross enrolment ratio (%) of Primary schools in 1997 to that in 2003?
Your answer should be very brief. 0.97. What is the ratio of the Gross enrolment ratio (%) of Secondary schools in 1997 to that in 2003?
Give a very brief answer. 1.01. What is the ratio of the Gross enrolment ratio (%) of Tertiary schools in 1997 to that in 2003?
Keep it short and to the point. 0.75. What is the ratio of the Gross enrolment ratio (%) of Pre-primary schools in 1997 to that in 2004?
Provide a succinct answer. 0.99. What is the ratio of the Gross enrolment ratio (%) in Primary schools in 1997 to that in 2004?
Offer a very short reply. 0.98. What is the ratio of the Gross enrolment ratio (%) of Secondary schools in 1997 to that in 2004?
Keep it short and to the point. 1.01. What is the ratio of the Gross enrolment ratio (%) in Tertiary schools in 1997 to that in 2004?
Your answer should be very brief. 0.75. What is the ratio of the Gross enrolment ratio (%) of Pre-primary schools in 1997 to that in 2005?
Offer a very short reply. 0.89. What is the ratio of the Gross enrolment ratio (%) of Primary schools in 1997 to that in 2005?
Make the answer very short. 1. What is the ratio of the Gross enrolment ratio (%) in Tertiary schools in 1997 to that in 2005?
Keep it short and to the point. 0.66. What is the ratio of the Gross enrolment ratio (%) in Tertiary schools in 1999 to that in 2000?
Your answer should be compact. 0.94. What is the ratio of the Gross enrolment ratio (%) in Pre-primary schools in 1999 to that in 2001?
Give a very brief answer. 1.02. What is the ratio of the Gross enrolment ratio (%) of Primary schools in 1999 to that in 2001?
Make the answer very short. 0.97. What is the ratio of the Gross enrolment ratio (%) of Secondary schools in 1999 to that in 2001?
Give a very brief answer. 1.01. What is the ratio of the Gross enrolment ratio (%) in Tertiary schools in 1999 to that in 2001?
Offer a terse response. 0.81. What is the ratio of the Gross enrolment ratio (%) of Pre-primary schools in 1999 to that in 2003?
Your response must be concise. 1.05. What is the ratio of the Gross enrolment ratio (%) of Primary schools in 1999 to that in 2003?
Make the answer very short. 0.99. What is the ratio of the Gross enrolment ratio (%) of Secondary schools in 1999 to that in 2003?
Keep it short and to the point. 1.01. What is the ratio of the Gross enrolment ratio (%) in Tertiary schools in 1999 to that in 2003?
Give a very brief answer. 0.8. What is the ratio of the Gross enrolment ratio (%) of Pre-primary schools in 1999 to that in 2004?
Keep it short and to the point. 1.03. What is the ratio of the Gross enrolment ratio (%) of Secondary schools in 1999 to that in 2004?
Ensure brevity in your answer.  1.01. What is the ratio of the Gross enrolment ratio (%) of Tertiary schools in 1999 to that in 2004?
Your answer should be compact. 0.81. What is the ratio of the Gross enrolment ratio (%) in Pre-primary schools in 1999 to that in 2005?
Offer a terse response. 0.93. What is the ratio of the Gross enrolment ratio (%) in Primary schools in 1999 to that in 2005?
Your answer should be compact. 1.01. What is the ratio of the Gross enrolment ratio (%) in Secondary schools in 1999 to that in 2005?
Offer a terse response. 1. What is the ratio of the Gross enrolment ratio (%) in Tertiary schools in 1999 to that in 2005?
Provide a short and direct response. 0.72. What is the ratio of the Gross enrolment ratio (%) in Pre-primary schools in 2000 to that in 2001?
Offer a very short reply. 1.06. What is the ratio of the Gross enrolment ratio (%) of Primary schools in 2000 to that in 2001?
Keep it short and to the point. 1.01. What is the ratio of the Gross enrolment ratio (%) in Secondary schools in 2000 to that in 2001?
Provide a succinct answer. 1.01. What is the ratio of the Gross enrolment ratio (%) in Tertiary schools in 2000 to that in 2001?
Provide a succinct answer. 0.86. What is the ratio of the Gross enrolment ratio (%) in Pre-primary schools in 2000 to that in 2003?
Your answer should be very brief. 1.08. What is the ratio of the Gross enrolment ratio (%) in Primary schools in 2000 to that in 2003?
Your response must be concise. 1.02. What is the ratio of the Gross enrolment ratio (%) in Secondary schools in 2000 to that in 2003?
Make the answer very short. 1.02. What is the ratio of the Gross enrolment ratio (%) of Tertiary schools in 2000 to that in 2003?
Your answer should be very brief. 0.85. What is the ratio of the Gross enrolment ratio (%) of Pre-primary schools in 2000 to that in 2004?
Offer a terse response. 1.07. What is the ratio of the Gross enrolment ratio (%) in Primary schools in 2000 to that in 2004?
Keep it short and to the point. 1.03. What is the ratio of the Gross enrolment ratio (%) of Secondary schools in 2000 to that in 2004?
Ensure brevity in your answer.  1.02. What is the ratio of the Gross enrolment ratio (%) in Tertiary schools in 2000 to that in 2004?
Give a very brief answer. 0.86. What is the ratio of the Gross enrolment ratio (%) in Pre-primary schools in 2000 to that in 2005?
Ensure brevity in your answer.  0.96. What is the ratio of the Gross enrolment ratio (%) of Primary schools in 2000 to that in 2005?
Keep it short and to the point. 1.04. What is the ratio of the Gross enrolment ratio (%) in Secondary schools in 2000 to that in 2005?
Offer a terse response. 1.01. What is the ratio of the Gross enrolment ratio (%) of Tertiary schools in 2000 to that in 2005?
Provide a short and direct response. 0.76. What is the ratio of the Gross enrolment ratio (%) of Pre-primary schools in 2001 to that in 2003?
Keep it short and to the point. 1.03. What is the ratio of the Gross enrolment ratio (%) of Primary schools in 2001 to that in 2003?
Provide a succinct answer. 1.01. What is the ratio of the Gross enrolment ratio (%) of Pre-primary schools in 2001 to that in 2004?
Your response must be concise. 1.01. What is the ratio of the Gross enrolment ratio (%) of Primary schools in 2001 to that in 2004?
Make the answer very short. 1.02. What is the ratio of the Gross enrolment ratio (%) in Secondary schools in 2001 to that in 2004?
Provide a succinct answer. 1.01. What is the ratio of the Gross enrolment ratio (%) in Tertiary schools in 2001 to that in 2004?
Provide a short and direct response. 1. What is the ratio of the Gross enrolment ratio (%) of Pre-primary schools in 2001 to that in 2005?
Make the answer very short. 0.91. What is the ratio of the Gross enrolment ratio (%) of Primary schools in 2001 to that in 2005?
Ensure brevity in your answer.  1.04. What is the ratio of the Gross enrolment ratio (%) in Tertiary schools in 2001 to that in 2005?
Ensure brevity in your answer.  0.88. What is the ratio of the Gross enrolment ratio (%) of Pre-primary schools in 2003 to that in 2004?
Make the answer very short. 0.99. What is the ratio of the Gross enrolment ratio (%) in Primary schools in 2003 to that in 2004?
Offer a terse response. 1.01. What is the ratio of the Gross enrolment ratio (%) of Tertiary schools in 2003 to that in 2004?
Provide a succinct answer. 1.01. What is the ratio of the Gross enrolment ratio (%) in Pre-primary schools in 2003 to that in 2005?
Make the answer very short. 0.89. What is the ratio of the Gross enrolment ratio (%) of Primary schools in 2003 to that in 2005?
Give a very brief answer. 1.02. What is the ratio of the Gross enrolment ratio (%) of Tertiary schools in 2003 to that in 2005?
Make the answer very short. 0.89. What is the ratio of the Gross enrolment ratio (%) in Pre-primary schools in 2004 to that in 2005?
Keep it short and to the point. 0.9. What is the ratio of the Gross enrolment ratio (%) of Primary schools in 2004 to that in 2005?
Your answer should be very brief. 1.02. What is the ratio of the Gross enrolment ratio (%) of Secondary schools in 2004 to that in 2005?
Your answer should be compact. 0.99. What is the ratio of the Gross enrolment ratio (%) in Tertiary schools in 2004 to that in 2005?
Provide a succinct answer. 0.88. What is the difference between the highest and the second highest Gross enrolment ratio (%) of Pre-primary schools?
Your answer should be very brief. 1.21. What is the difference between the highest and the second highest Gross enrolment ratio (%) of Primary schools?
Your response must be concise. 0.9. What is the difference between the highest and the second highest Gross enrolment ratio (%) of Secondary schools?
Your answer should be compact. 0.56. What is the difference between the highest and the second highest Gross enrolment ratio (%) of Tertiary schools?
Ensure brevity in your answer.  2.09. What is the difference between the highest and the lowest Gross enrolment ratio (%) of Pre-primary schools?
Keep it short and to the point. 3.37. What is the difference between the highest and the lowest Gross enrolment ratio (%) of Primary schools?
Provide a succinct answer. 8.4. What is the difference between the highest and the lowest Gross enrolment ratio (%) in Secondary schools?
Your answer should be very brief. 1.94. What is the difference between the highest and the lowest Gross enrolment ratio (%) of Tertiary schools?
Keep it short and to the point. 6.74. 